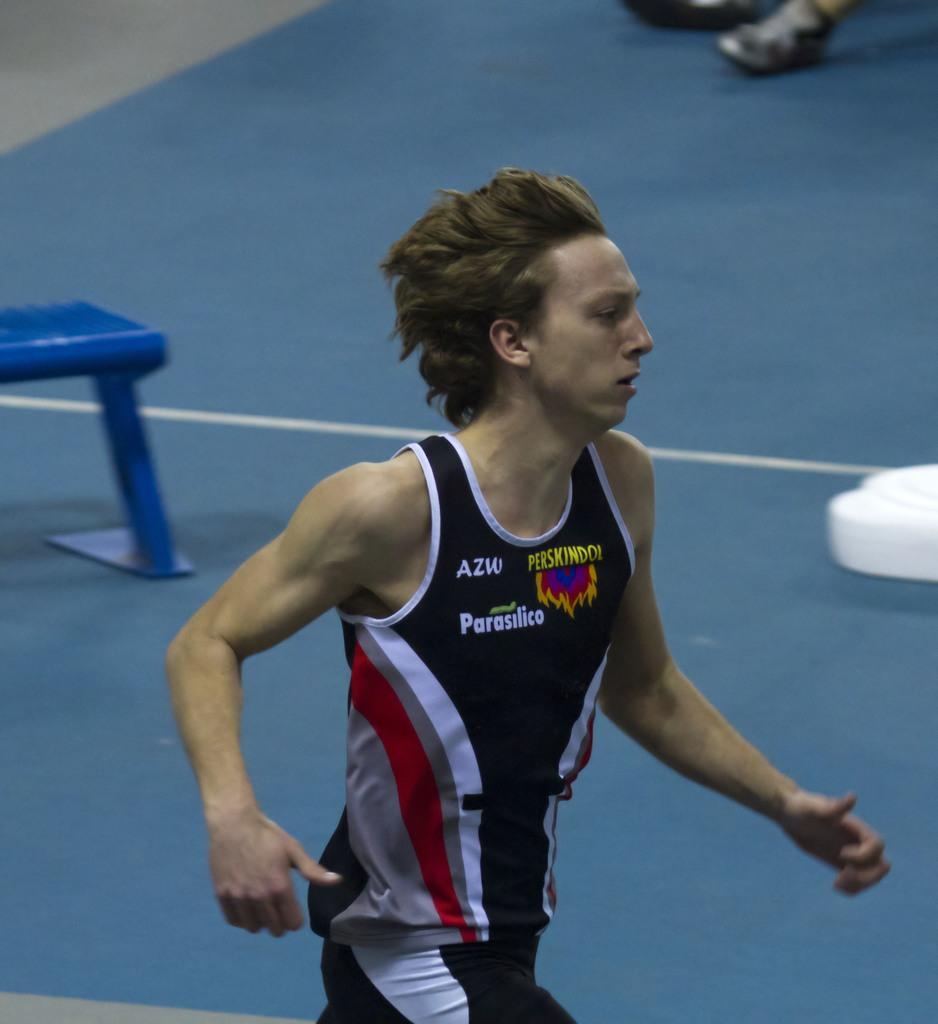<image>
Give a short and clear explanation of the subsequent image. An athlete wearing a black jersey with a Perskindol logo. 